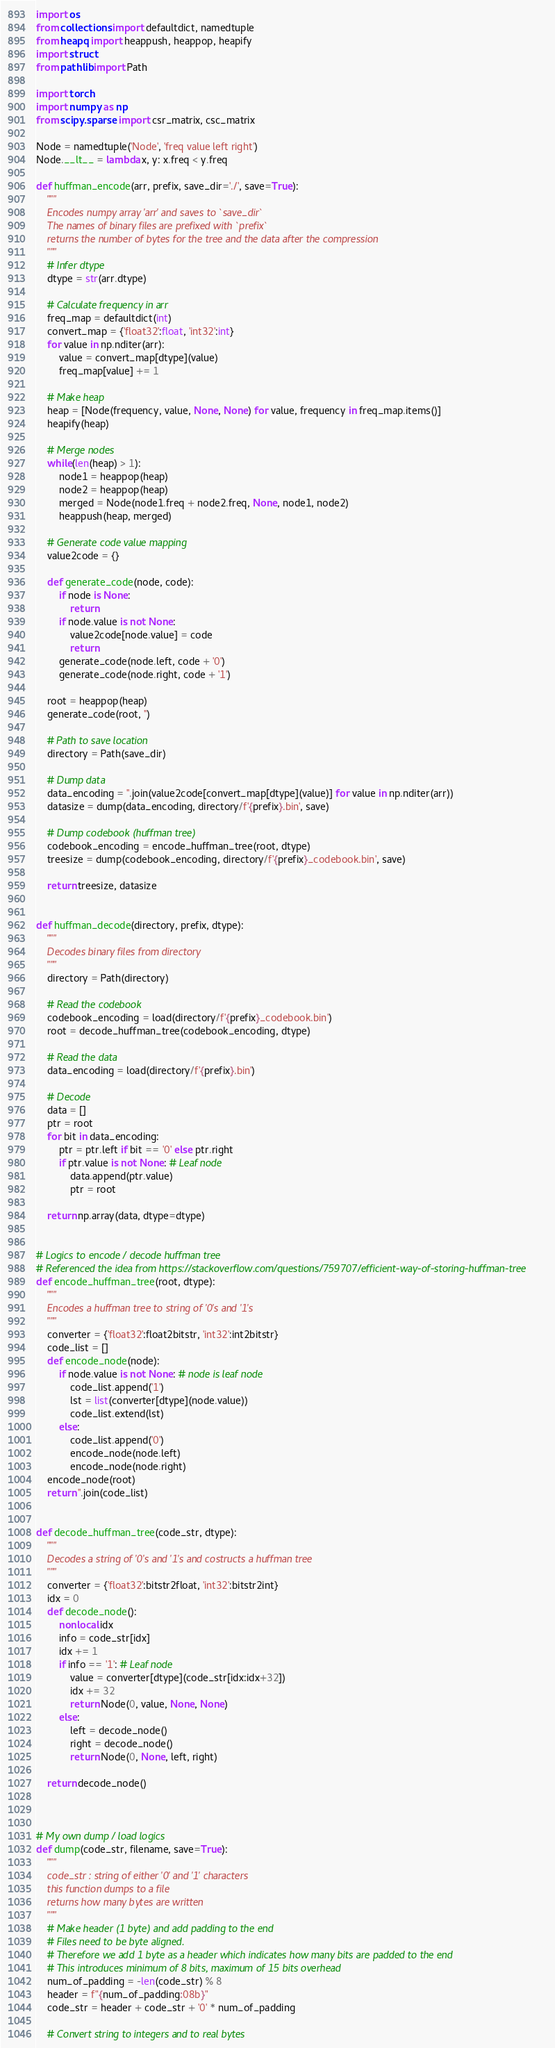Convert code to text. <code><loc_0><loc_0><loc_500><loc_500><_Python_>import os
from collections import defaultdict, namedtuple
from heapq import heappush, heappop, heapify
import struct
from pathlib import Path

import torch
import numpy as np
from scipy.sparse import csr_matrix, csc_matrix

Node = namedtuple('Node', 'freq value left right')
Node.__lt__ = lambda x, y: x.freq < y.freq

def huffman_encode(arr, prefix, save_dir='./', save=True):
    """
    Encodes numpy array 'arr' and saves to `save_dir`
    The names of binary files are prefixed with `prefix`
    returns the number of bytes for the tree and the data after the compression
    """
    # Infer dtype
    dtype = str(arr.dtype)

    # Calculate frequency in arr
    freq_map = defaultdict(int)
    convert_map = {'float32':float, 'int32':int}
    for value in np.nditer(arr):
        value = convert_map[dtype](value)
        freq_map[value] += 1

    # Make heap
    heap = [Node(frequency, value, None, None) for value, frequency in freq_map.items()]
    heapify(heap)

    # Merge nodes
    while(len(heap) > 1):
        node1 = heappop(heap)
        node2 = heappop(heap)
        merged = Node(node1.freq + node2.freq, None, node1, node2)
        heappush(heap, merged)

    # Generate code value mapping
    value2code = {}

    def generate_code(node, code):
        if node is None:
            return
        if node.value is not None:
            value2code[node.value] = code
            return
        generate_code(node.left, code + '0')
        generate_code(node.right, code + '1')

    root = heappop(heap)
    generate_code(root, '')

    # Path to save location
    directory = Path(save_dir)

    # Dump data
    data_encoding = ''.join(value2code[convert_map[dtype](value)] for value in np.nditer(arr))
    datasize = dump(data_encoding, directory/f'{prefix}.bin', save)

    # Dump codebook (huffman tree)
    codebook_encoding = encode_huffman_tree(root, dtype)
    treesize = dump(codebook_encoding, directory/f'{prefix}_codebook.bin', save)

    return treesize, datasize


def huffman_decode(directory, prefix, dtype):
    """
    Decodes binary files from directory
    """
    directory = Path(directory)

    # Read the codebook
    codebook_encoding = load(directory/f'{prefix}_codebook.bin')
    root = decode_huffman_tree(codebook_encoding, dtype)

    # Read the data
    data_encoding = load(directory/f'{prefix}.bin')

    # Decode
    data = []
    ptr = root
    for bit in data_encoding:
        ptr = ptr.left if bit == '0' else ptr.right
        if ptr.value is not None: # Leaf node
            data.append(ptr.value)
            ptr = root

    return np.array(data, dtype=dtype)


# Logics to encode / decode huffman tree
# Referenced the idea from https://stackoverflow.com/questions/759707/efficient-way-of-storing-huffman-tree
def encode_huffman_tree(root, dtype):
    """
    Encodes a huffman tree to string of '0's and '1's
    """
    converter = {'float32':float2bitstr, 'int32':int2bitstr}
    code_list = []
    def encode_node(node):
        if node.value is not None: # node is leaf node
            code_list.append('1')
            lst = list(converter[dtype](node.value))
            code_list.extend(lst)
        else:
            code_list.append('0')
            encode_node(node.left)
            encode_node(node.right)
    encode_node(root)
    return ''.join(code_list)


def decode_huffman_tree(code_str, dtype):
    """
    Decodes a string of '0's and '1's and costructs a huffman tree
    """
    converter = {'float32':bitstr2float, 'int32':bitstr2int}
    idx = 0
    def decode_node():
        nonlocal idx
        info = code_str[idx]
        idx += 1
        if info == '1': # Leaf node
            value = converter[dtype](code_str[idx:idx+32])
            idx += 32
            return Node(0, value, None, None)
        else:
            left = decode_node()
            right = decode_node()
            return Node(0, None, left, right)

    return decode_node()



# My own dump / load logics
def dump(code_str, filename, save=True):
    """
    code_str : string of either '0' and '1' characters
    this function dumps to a file
    returns how many bytes are written
    """
    # Make header (1 byte) and add padding to the end
    # Files need to be byte aligned.
    # Therefore we add 1 byte as a header which indicates how many bits are padded to the end
    # This introduces minimum of 8 bits, maximum of 15 bits overhead
    num_of_padding = -len(code_str) % 8
    header = f"{num_of_padding:08b}"
    code_str = header + code_str + '0' * num_of_padding

    # Convert string to integers and to real bytes</code> 